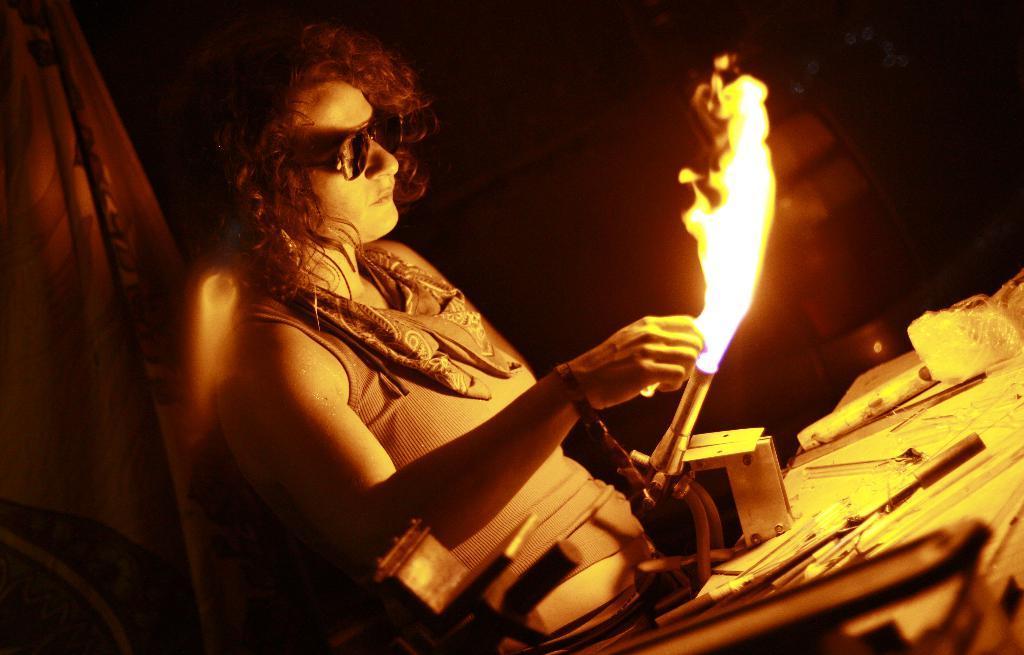Could you give a brief overview of what you see in this image? In the image there is a person with goggles and also there is a cloth around the neck. The person is holding a pipe with flame. And in front of that person there are few tools on the table. There is a dark background. On the left corner of the image there is a cloth. 